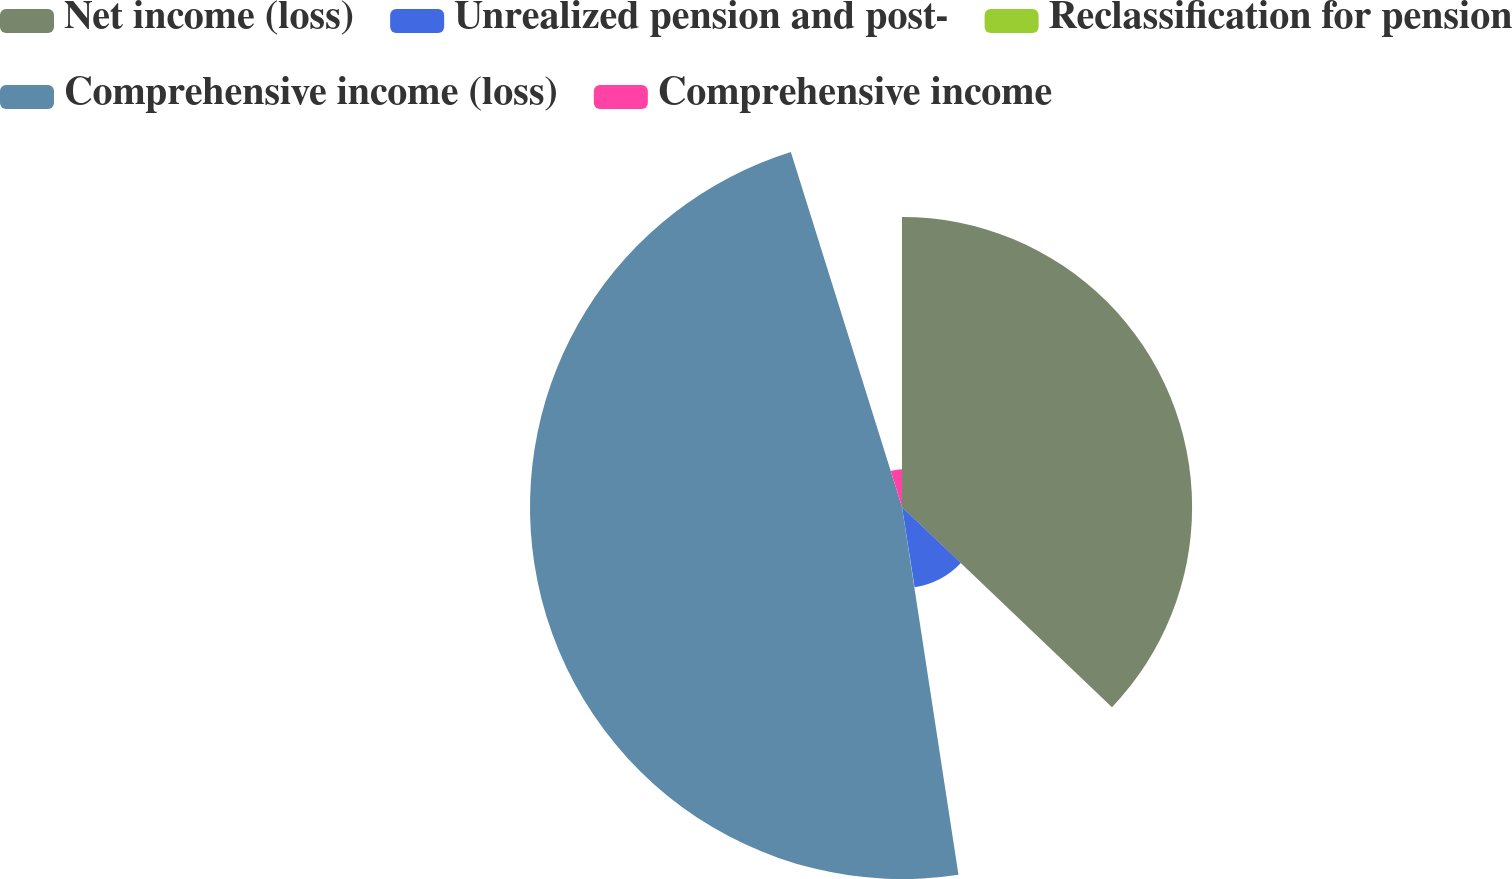<chart> <loc_0><loc_0><loc_500><loc_500><pie_chart><fcel>Net income (loss)<fcel>Unrealized pension and post-<fcel>Reclassification for pension<fcel>Comprehensive income (loss)<fcel>Comprehensive income<nl><fcel>37.12%<fcel>10.41%<fcel>0.05%<fcel>47.6%<fcel>4.83%<nl></chart> 